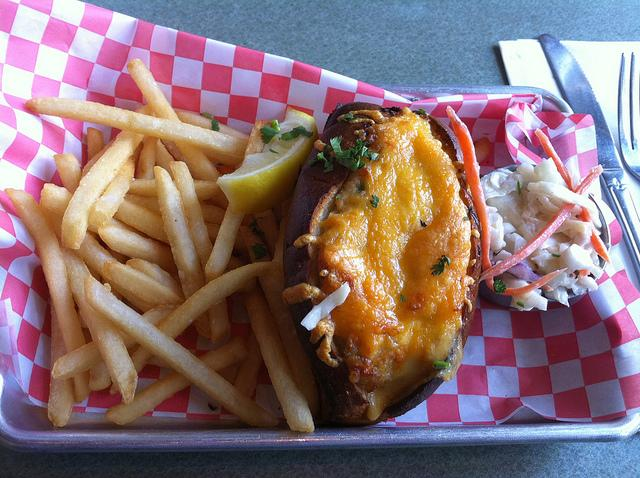Which food item on the plate is highest in fat? fries 